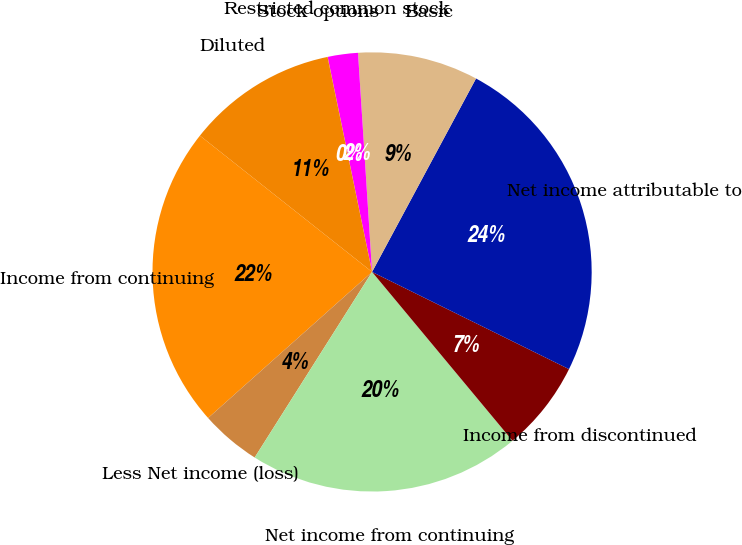Convert chart to OTSL. <chart><loc_0><loc_0><loc_500><loc_500><pie_chart><fcel>Income from continuing<fcel>Less Net income (loss)<fcel>Net income from continuing<fcel>Income from discontinued<fcel>Net income attributable to<fcel>Basic<fcel>Restricted common stock<fcel>Stock options<fcel>Diluted<nl><fcel>22.24%<fcel>4.44%<fcel>20.02%<fcel>6.66%<fcel>24.45%<fcel>8.87%<fcel>2.22%<fcel>0.01%<fcel>11.09%<nl></chart> 